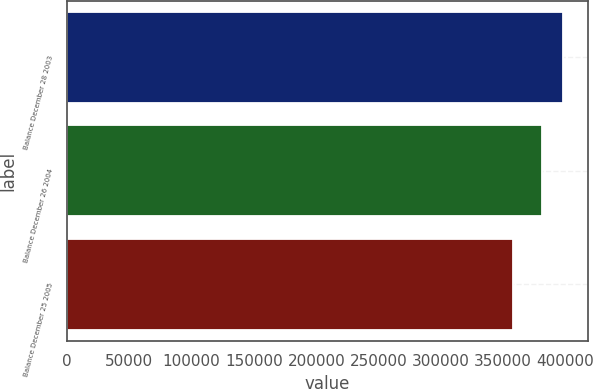<chart> <loc_0><loc_0><loc_500><loc_500><bar_chart><fcel>Balance December 28 2003<fcel>Balance December 26 2004<fcel>Balance December 25 2005<nl><fcel>397878<fcel>380745<fcel>358199<nl></chart> 